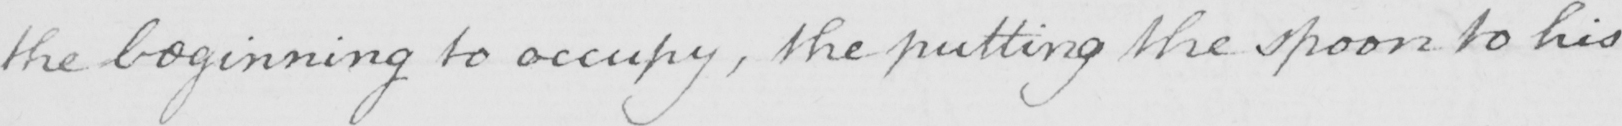Can you read and transcribe this handwriting? the beginning to occupy , the putting the spoon to his 